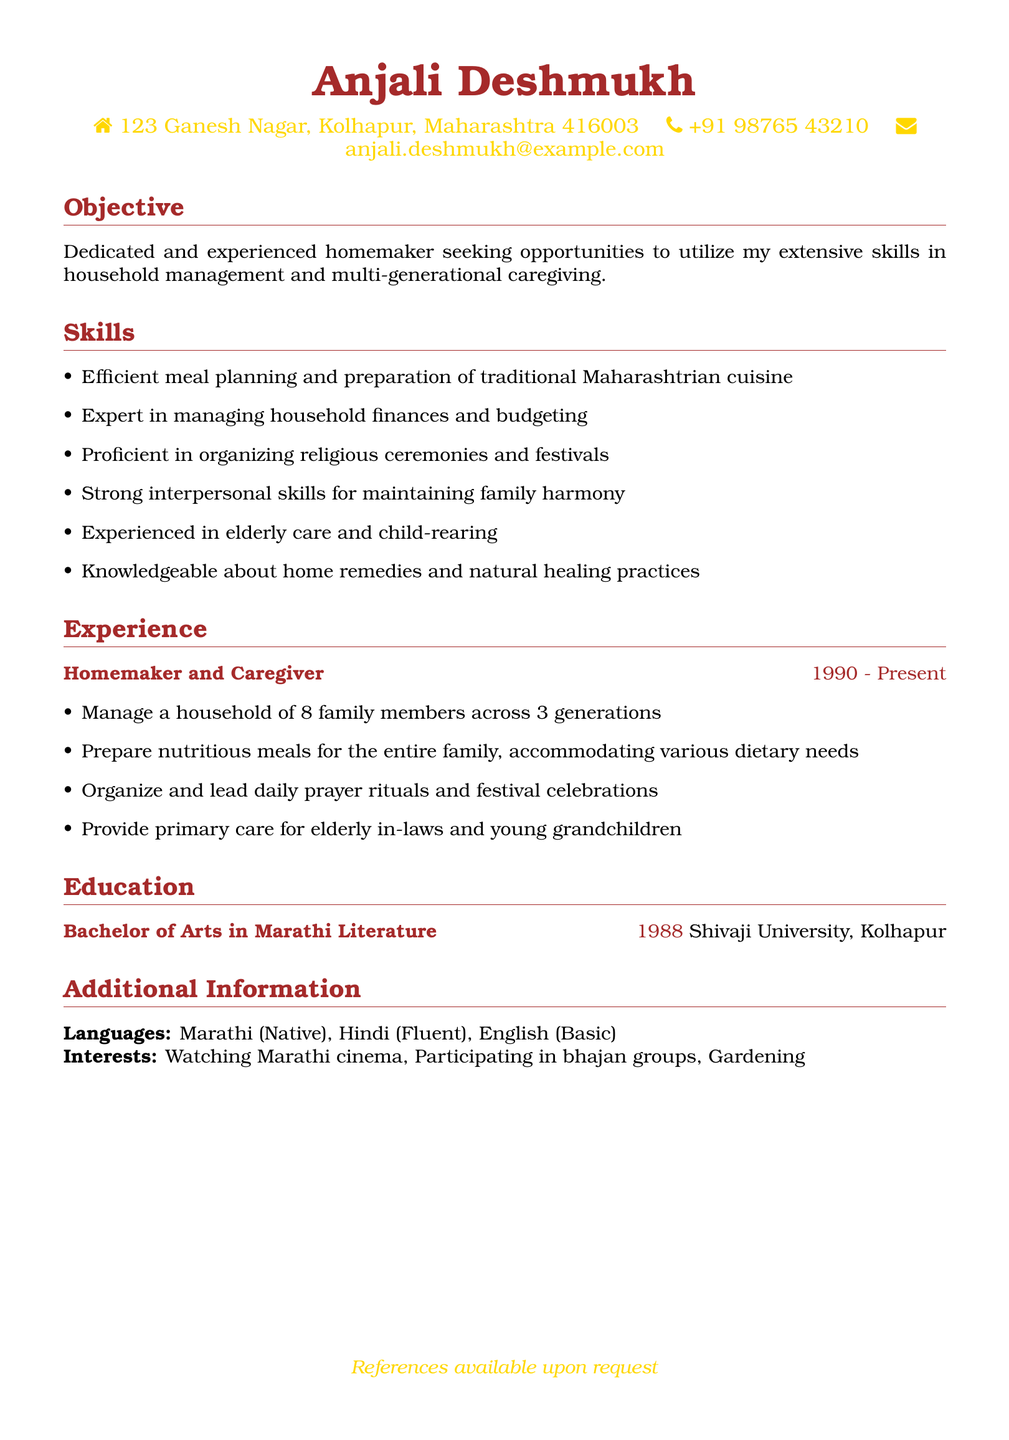What is the name of the person in the CV? The name of the person is clearly stated at the top of the document.
Answer: Anjali Deshmukh What is the contact phone number? The CV provides a phone number in the personal information section.
Answer: +91 98765 43210 In which year did Anjali complete her degree? The year of graduation is mentioned in the education section.
Answer: 1988 How many family members are managed in the household? The responsibilities indicate the number of family members living in the household.
Answer: 8 What type of cuisine is Anjali proficient in preparing? The skills section mentions a specific type of cuisine she is familiar with.
Answer: Maharashtrian cuisine What is one of Anjali's key skills related to religious practices? The skills section outlines her proficiency related to this area.
Answer: Organizing religious ceremonies What language is Anjali a native speaker of? The additional information includes the languages she speaks, highlighting her native language.
Answer: Marathi What is Anjali's academic background? The education section states the degree she obtained from an institution.
Answer: Bachelor of Arts in Marathi Literature What type of care experience does Anjali have? The experience section describes her caregiving responsibilities, including who she cares for.
Answer: Elderly care and child-rearing What are Anjali's interests outside of her household duties? The additional information lists her personal interests distinct from her professional roles.
Answer: Watching Marathi cinema 